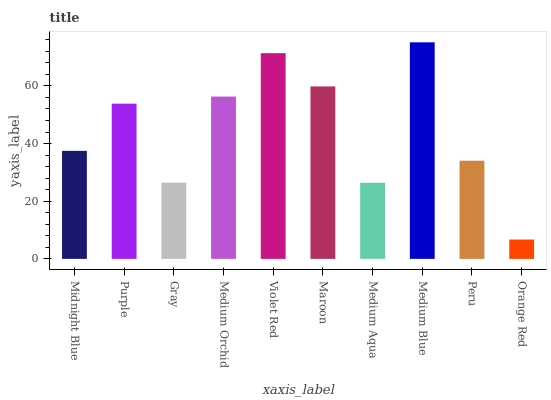Is Orange Red the minimum?
Answer yes or no. Yes. Is Medium Blue the maximum?
Answer yes or no. Yes. Is Purple the minimum?
Answer yes or no. No. Is Purple the maximum?
Answer yes or no. No. Is Purple greater than Midnight Blue?
Answer yes or no. Yes. Is Midnight Blue less than Purple?
Answer yes or no. Yes. Is Midnight Blue greater than Purple?
Answer yes or no. No. Is Purple less than Midnight Blue?
Answer yes or no. No. Is Purple the high median?
Answer yes or no. Yes. Is Midnight Blue the low median?
Answer yes or no. Yes. Is Medium Orchid the high median?
Answer yes or no. No. Is Purple the low median?
Answer yes or no. No. 